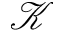Convert formula to latex. <formula><loc_0><loc_0><loc_500><loc_500>\mathcal { K }</formula> 